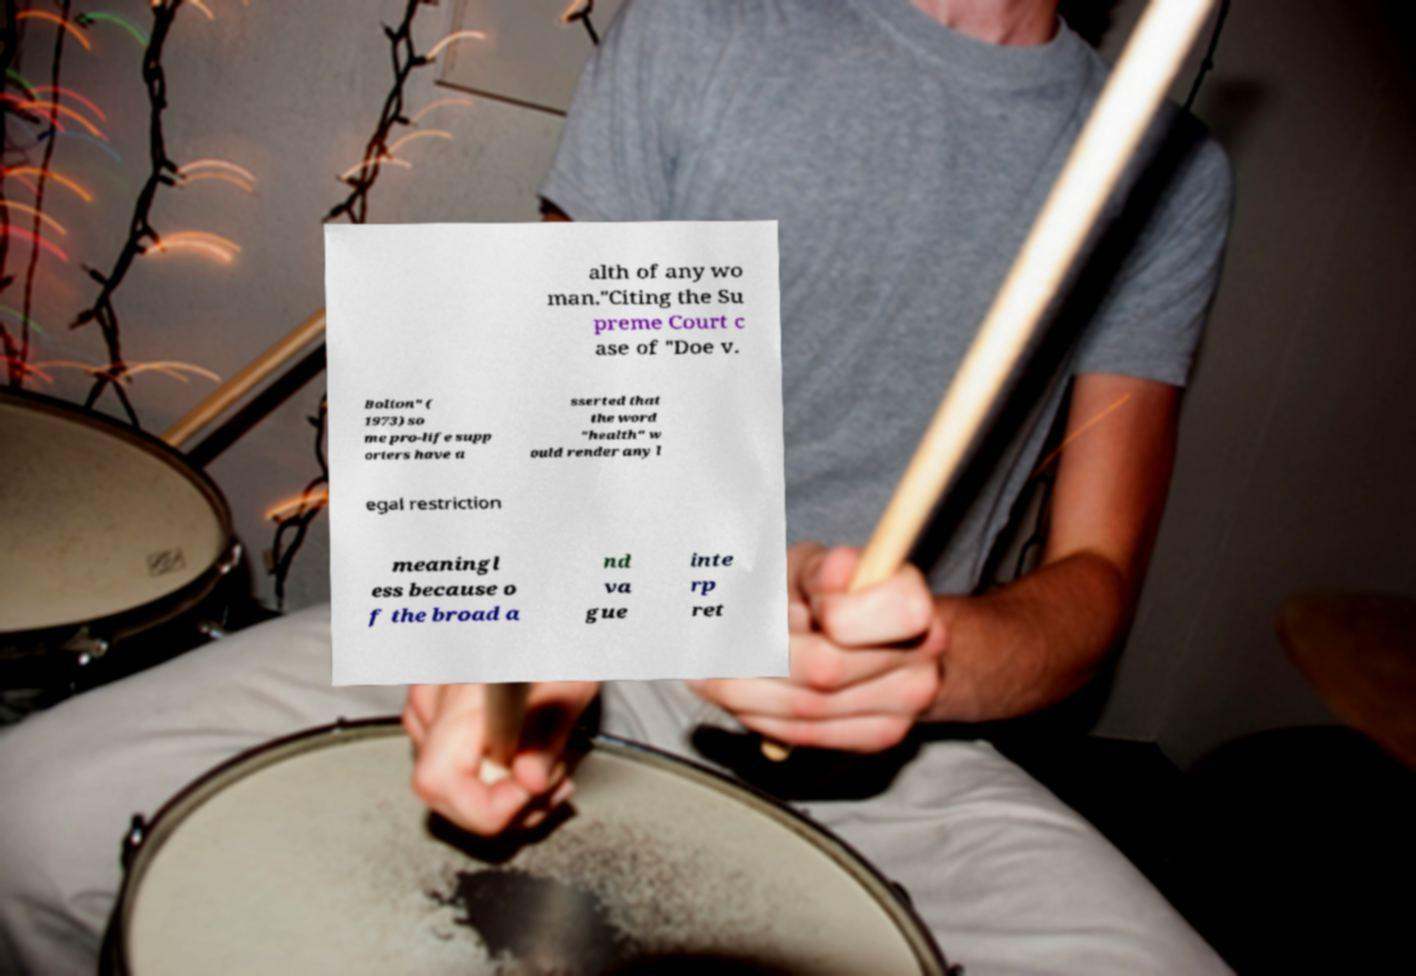There's text embedded in this image that I need extracted. Can you transcribe it verbatim? alth of any wo man."Citing the Su preme Court c ase of "Doe v. Bolton" ( 1973) so me pro-life supp orters have a sserted that the word "health" w ould render any l egal restriction meaningl ess because o f the broad a nd va gue inte rp ret 